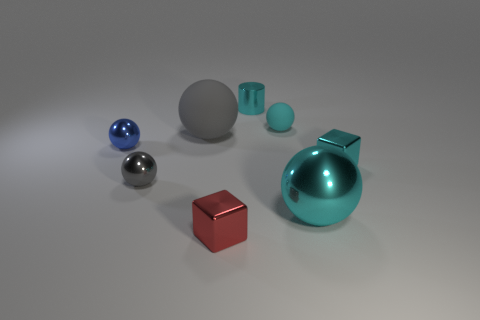Add 2 small blue metal spheres. How many objects exist? 10 Subtract all gray matte balls. How many balls are left? 4 Subtract all gray spheres. How many spheres are left? 3 Subtract 2 gray balls. How many objects are left? 6 Subtract all cubes. How many objects are left? 6 Subtract 1 cylinders. How many cylinders are left? 0 Subtract all purple cubes. Subtract all green cylinders. How many cubes are left? 2 Subtract all yellow cylinders. How many purple blocks are left? 0 Subtract all green metal objects. Subtract all rubber things. How many objects are left? 6 Add 6 large gray objects. How many large gray objects are left? 7 